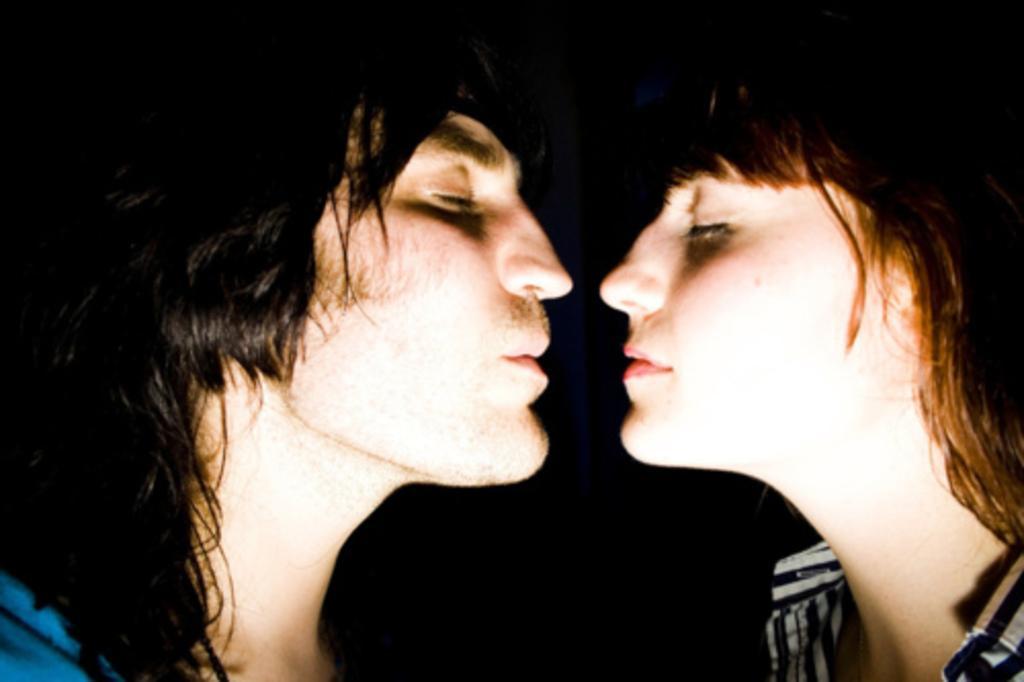Can you describe this image briefly? In this image we can see two persons wearing dress. 